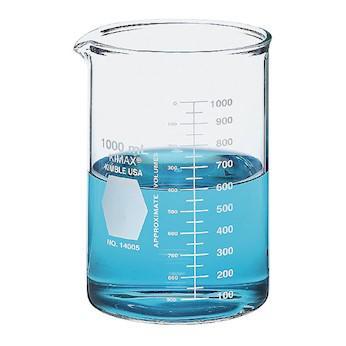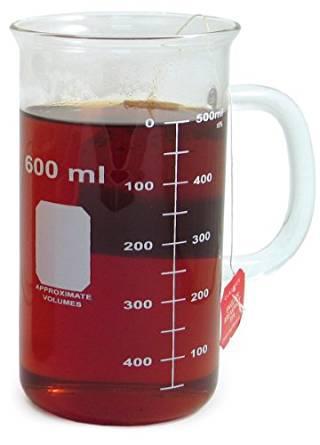The first image is the image on the left, the second image is the image on the right. For the images displayed, is the sentence "One beaker is filled with blue liquid, and one beaker is filled with reddish liquid." factually correct? Answer yes or no. Yes. The first image is the image on the left, the second image is the image on the right. Analyze the images presented: Is the assertion "The left and right image contains the same number of full beakers." valid? Answer yes or no. Yes. 